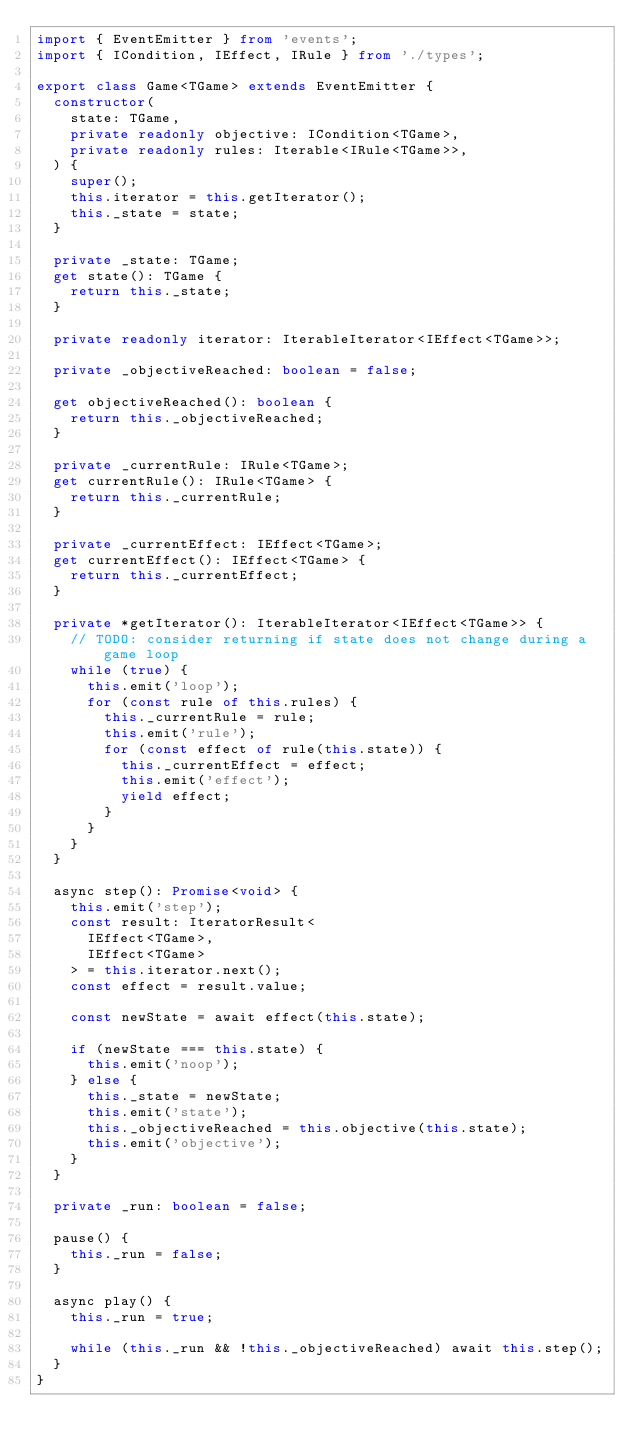Convert code to text. <code><loc_0><loc_0><loc_500><loc_500><_TypeScript_>import { EventEmitter } from 'events';
import { ICondition, IEffect, IRule } from './types';

export class Game<TGame> extends EventEmitter {
  constructor(
    state: TGame,
    private readonly objective: ICondition<TGame>,
    private readonly rules: Iterable<IRule<TGame>>,
  ) {
    super();
    this.iterator = this.getIterator();
    this._state = state;
  }

  private _state: TGame;
  get state(): TGame {
    return this._state;
  }

  private readonly iterator: IterableIterator<IEffect<TGame>>;

  private _objectiveReached: boolean = false;

  get objectiveReached(): boolean {
    return this._objectiveReached;
  }

  private _currentRule: IRule<TGame>;
  get currentRule(): IRule<TGame> {
    return this._currentRule;
  }

  private _currentEffect: IEffect<TGame>;
  get currentEffect(): IEffect<TGame> {
    return this._currentEffect;
  }

  private *getIterator(): IterableIterator<IEffect<TGame>> {
    // TODO: consider returning if state does not change during a game loop
    while (true) {
      this.emit('loop');
      for (const rule of this.rules) {
        this._currentRule = rule;
        this.emit('rule');
        for (const effect of rule(this.state)) {
          this._currentEffect = effect;
          this.emit('effect');
          yield effect;
        }
      }
    }
  }

  async step(): Promise<void> {
    this.emit('step');
    const result: IteratorResult<
      IEffect<TGame>,
      IEffect<TGame>
    > = this.iterator.next();
    const effect = result.value;

    const newState = await effect(this.state);

    if (newState === this.state) {
      this.emit('noop');
    } else {
      this._state = newState;
      this.emit('state');
      this._objectiveReached = this.objective(this.state);
      this.emit('objective');
    }
  }

  private _run: boolean = false;

  pause() {
    this._run = false;
  }

  async play() {
    this._run = true;

    while (this._run && !this._objectiveReached) await this.step();
  }
}
</code> 